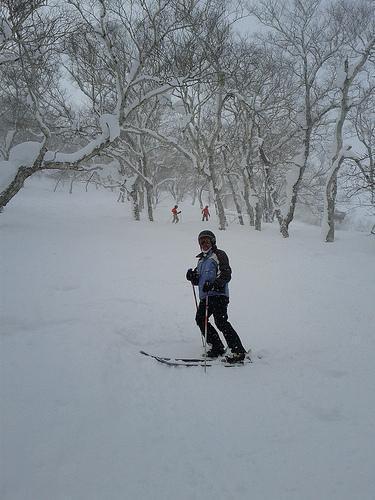How many leaves are on the trees?
Give a very brief answer. 0. How many people are in the background?
Give a very brief answer. 2. How many people (total) are in the photo?
Give a very brief answer. 3. How many people are wearing red?
Give a very brief answer. 2. 